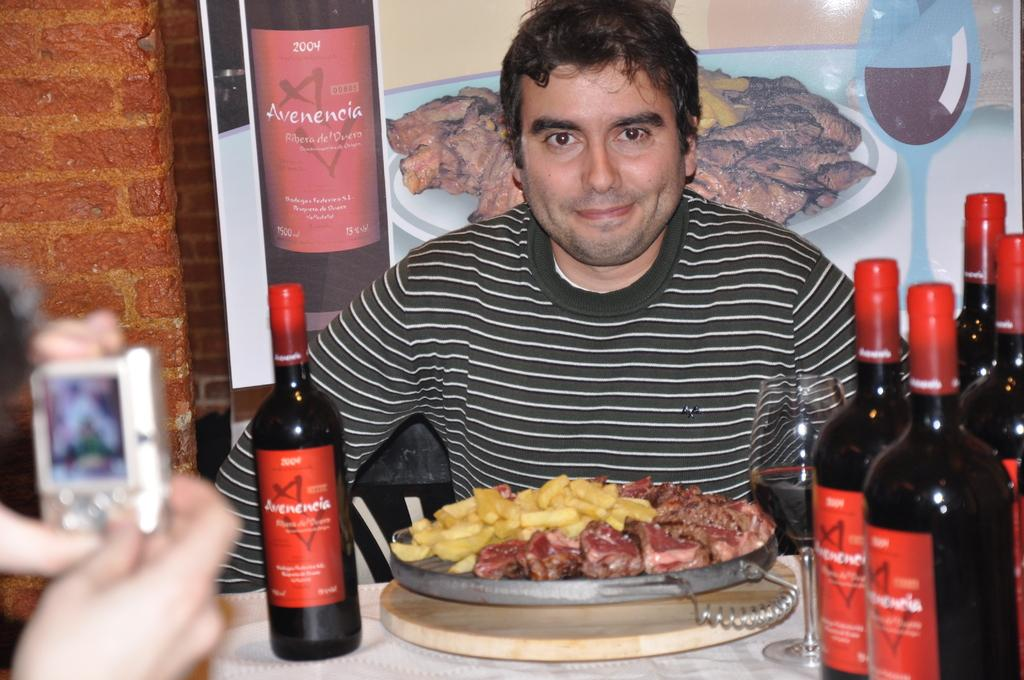<image>
Write a terse but informative summary of the picture. Bottles of Avenencia are on the table and on a poster on the wall. 